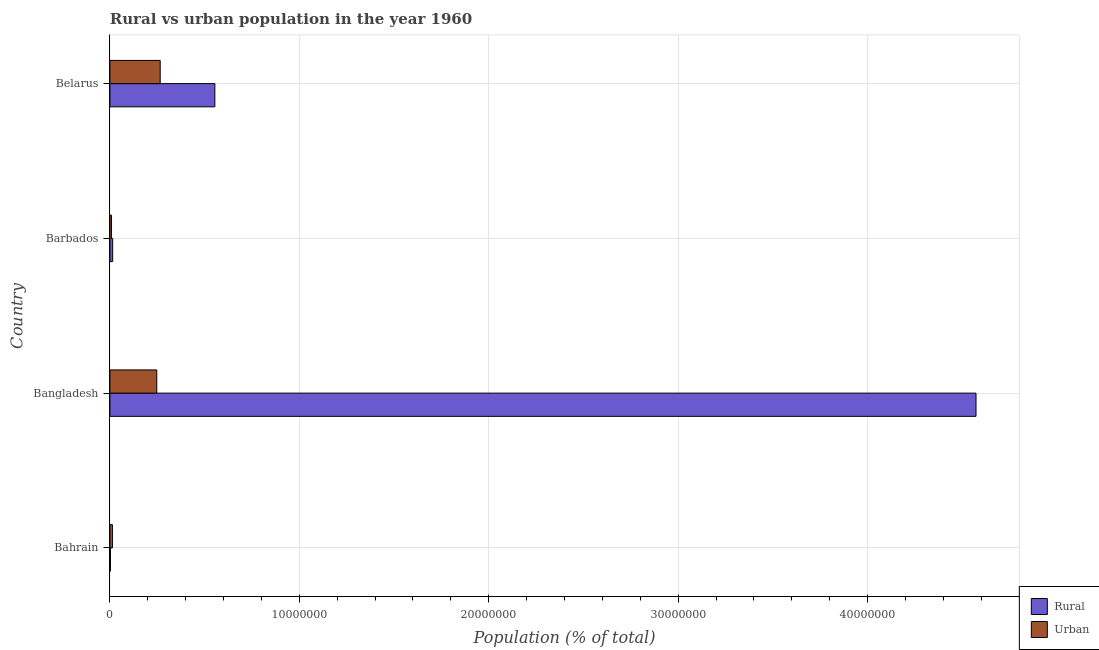Are the number of bars per tick equal to the number of legend labels?
Make the answer very short. Yes. Are the number of bars on each tick of the Y-axis equal?
Your response must be concise. Yes. What is the label of the 2nd group of bars from the top?
Give a very brief answer. Barbados. What is the urban population density in Bangladesh?
Ensure brevity in your answer.  2.48e+06. Across all countries, what is the maximum urban population density?
Your response must be concise. 2.66e+06. Across all countries, what is the minimum rural population density?
Your response must be concise. 2.87e+04. In which country was the urban population density maximum?
Keep it short and to the point. Belarus. In which country was the rural population density minimum?
Ensure brevity in your answer.  Bahrain. What is the total urban population density in the graph?
Offer a very short reply. 5.35e+06. What is the difference between the rural population density in Bahrain and that in Belarus?
Your answer should be compact. -5.51e+06. What is the difference between the urban population density in Bangladesh and the rural population density in Belarus?
Your answer should be very brief. -3.07e+06. What is the average urban population density per country?
Give a very brief answer. 1.34e+06. What is the difference between the urban population density and rural population density in Bangladesh?
Your response must be concise. -4.33e+07. Is the rural population density in Bangladesh less than that in Barbados?
Your answer should be very brief. No. What is the difference between the highest and the second highest urban population density?
Keep it short and to the point. 1.81e+05. What is the difference between the highest and the lowest rural population density?
Your answer should be compact. 4.57e+07. Is the sum of the urban population density in Bangladesh and Barbados greater than the maximum rural population density across all countries?
Keep it short and to the point. No. What does the 2nd bar from the top in Belarus represents?
Your answer should be very brief. Rural. What does the 2nd bar from the bottom in Bangladesh represents?
Your answer should be very brief. Urban. Are all the bars in the graph horizontal?
Your response must be concise. Yes. Does the graph contain grids?
Offer a terse response. Yes. How are the legend labels stacked?
Provide a succinct answer. Vertical. What is the title of the graph?
Give a very brief answer. Rural vs urban population in the year 1960. What is the label or title of the X-axis?
Offer a very short reply. Population (% of total). What is the Population (% of total) of Rural in Bahrain?
Your answer should be compact. 2.87e+04. What is the Population (% of total) of Urban in Bahrain?
Give a very brief answer. 1.34e+05. What is the Population (% of total) of Rural in Bangladesh?
Keep it short and to the point. 4.57e+07. What is the Population (% of total) in Urban in Bangladesh?
Your answer should be compact. 2.48e+06. What is the Population (% of total) of Rural in Barbados?
Ensure brevity in your answer.  1.46e+05. What is the Population (% of total) in Urban in Barbados?
Your answer should be compact. 8.49e+04. What is the Population (% of total) of Rural in Belarus?
Provide a short and direct response. 5.54e+06. What is the Population (% of total) in Urban in Belarus?
Keep it short and to the point. 2.66e+06. Across all countries, what is the maximum Population (% of total) of Rural?
Offer a very short reply. 4.57e+07. Across all countries, what is the maximum Population (% of total) in Urban?
Give a very brief answer. 2.66e+06. Across all countries, what is the minimum Population (% of total) of Rural?
Give a very brief answer. 2.87e+04. Across all countries, what is the minimum Population (% of total) in Urban?
Your answer should be very brief. 8.49e+04. What is the total Population (% of total) of Rural in the graph?
Make the answer very short. 5.14e+07. What is the total Population (% of total) of Urban in the graph?
Make the answer very short. 5.35e+06. What is the difference between the Population (% of total) of Rural in Bahrain and that in Bangladesh?
Provide a succinct answer. -4.57e+07. What is the difference between the Population (% of total) of Urban in Bahrain and that in Bangladesh?
Give a very brief answer. -2.34e+06. What is the difference between the Population (% of total) of Rural in Bahrain and that in Barbados?
Your answer should be compact. -1.17e+05. What is the difference between the Population (% of total) in Urban in Bahrain and that in Barbados?
Give a very brief answer. 4.88e+04. What is the difference between the Population (% of total) of Rural in Bahrain and that in Belarus?
Provide a short and direct response. -5.51e+06. What is the difference between the Population (% of total) of Urban in Bahrain and that in Belarus?
Ensure brevity in your answer.  -2.52e+06. What is the difference between the Population (% of total) in Rural in Bangladesh and that in Barbados?
Give a very brief answer. 4.56e+07. What is the difference between the Population (% of total) in Urban in Bangladesh and that in Barbados?
Provide a short and direct response. 2.39e+06. What is the difference between the Population (% of total) of Rural in Bangladesh and that in Belarus?
Give a very brief answer. 4.02e+07. What is the difference between the Population (% of total) in Urban in Bangladesh and that in Belarus?
Give a very brief answer. -1.81e+05. What is the difference between the Population (% of total) of Rural in Barbados and that in Belarus?
Your response must be concise. -5.40e+06. What is the difference between the Population (% of total) of Urban in Barbados and that in Belarus?
Keep it short and to the point. -2.57e+06. What is the difference between the Population (% of total) in Rural in Bahrain and the Population (% of total) in Urban in Bangladesh?
Offer a terse response. -2.45e+06. What is the difference between the Population (% of total) in Rural in Bahrain and the Population (% of total) in Urban in Barbados?
Keep it short and to the point. -5.62e+04. What is the difference between the Population (% of total) of Rural in Bahrain and the Population (% of total) of Urban in Belarus?
Ensure brevity in your answer.  -2.63e+06. What is the difference between the Population (% of total) in Rural in Bangladesh and the Population (% of total) in Urban in Barbados?
Make the answer very short. 4.56e+07. What is the difference between the Population (% of total) in Rural in Bangladesh and the Population (% of total) in Urban in Belarus?
Offer a terse response. 4.31e+07. What is the difference between the Population (% of total) in Rural in Barbados and the Population (% of total) in Urban in Belarus?
Give a very brief answer. -2.51e+06. What is the average Population (% of total) in Rural per country?
Your answer should be very brief. 1.29e+07. What is the average Population (% of total) in Urban per country?
Give a very brief answer. 1.34e+06. What is the difference between the Population (% of total) of Rural and Population (% of total) of Urban in Bahrain?
Make the answer very short. -1.05e+05. What is the difference between the Population (% of total) of Rural and Population (% of total) of Urban in Bangladesh?
Make the answer very short. 4.33e+07. What is the difference between the Population (% of total) of Rural and Population (% of total) of Urban in Barbados?
Keep it short and to the point. 6.11e+04. What is the difference between the Population (% of total) in Rural and Population (% of total) in Urban in Belarus?
Give a very brief answer. 2.89e+06. What is the ratio of the Population (% of total) of Rural in Bahrain to that in Bangladesh?
Make the answer very short. 0. What is the ratio of the Population (% of total) of Urban in Bahrain to that in Bangladesh?
Your answer should be very brief. 0.05. What is the ratio of the Population (% of total) in Rural in Bahrain to that in Barbados?
Your response must be concise. 0.2. What is the ratio of the Population (% of total) in Urban in Bahrain to that in Barbados?
Your answer should be compact. 1.58. What is the ratio of the Population (% of total) in Rural in Bahrain to that in Belarus?
Provide a succinct answer. 0.01. What is the ratio of the Population (% of total) in Urban in Bahrain to that in Belarus?
Offer a very short reply. 0.05. What is the ratio of the Population (% of total) of Rural in Bangladesh to that in Barbados?
Make the answer very short. 313.18. What is the ratio of the Population (% of total) in Urban in Bangladesh to that in Barbados?
Give a very brief answer. 29.14. What is the ratio of the Population (% of total) in Rural in Bangladesh to that in Belarus?
Provide a short and direct response. 8.25. What is the ratio of the Population (% of total) of Urban in Bangladesh to that in Belarus?
Make the answer very short. 0.93. What is the ratio of the Population (% of total) of Rural in Barbados to that in Belarus?
Give a very brief answer. 0.03. What is the ratio of the Population (% of total) of Urban in Barbados to that in Belarus?
Ensure brevity in your answer.  0.03. What is the difference between the highest and the second highest Population (% of total) of Rural?
Provide a short and direct response. 4.02e+07. What is the difference between the highest and the second highest Population (% of total) in Urban?
Offer a very short reply. 1.81e+05. What is the difference between the highest and the lowest Population (% of total) of Rural?
Your response must be concise. 4.57e+07. What is the difference between the highest and the lowest Population (% of total) in Urban?
Offer a terse response. 2.57e+06. 